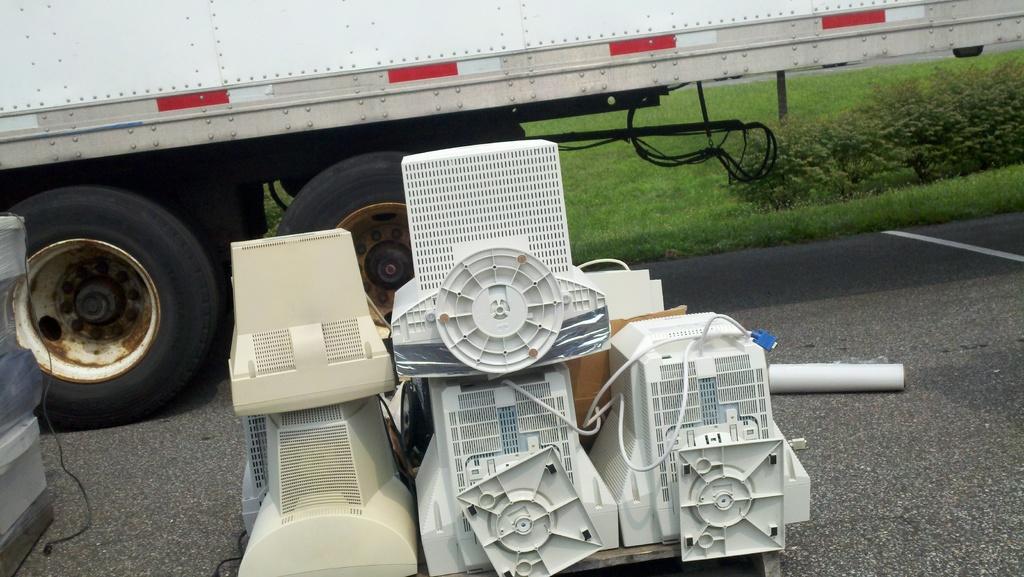In one or two sentences, can you explain what this image depicts? In the picture we can see some machines on the road surface and behind it, we can see a part of the truck with two wheels and beside it we can see the grass surface. 